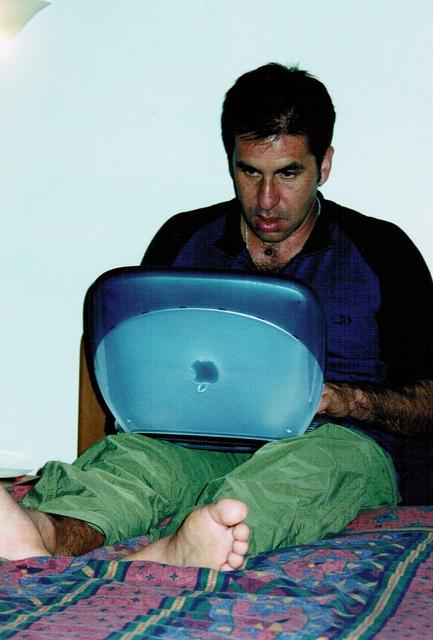What type of computer is this?
Answer briefly. Apple. How many toes are visible in this photo?
Short answer required. 5. What color is the computer?
Write a very short answer. Blue. 